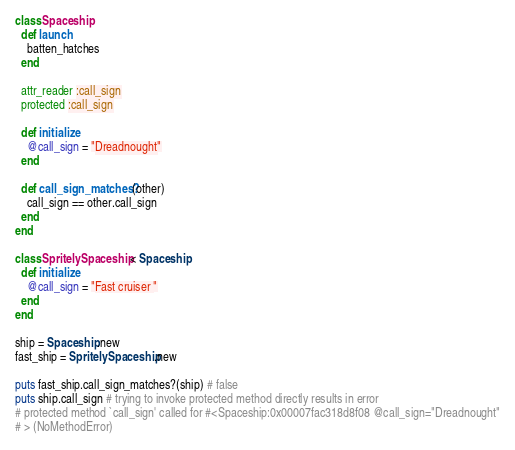<code> <loc_0><loc_0><loc_500><loc_500><_Ruby_>class Spaceship
  def launch
    batten_hatches
  end

  attr_reader :call_sign
  protected :call_sign

  def initialize
    @call_sign = "Dreadnought"
  end

  def call_sign_matches?(other)
    call_sign == other.call_sign
  end
end

class SpritelySpaceship < Spaceship
  def initialize
    @call_sign = "Fast cruiser "
  end
end

ship = Spaceship.new
fast_ship = SpritelySpaceship.new

puts fast_ship.call_sign_matches?(ship) # false
puts ship.call_sign # trying to invoke protected method directly results in error
# protected method `call_sign' called for #<Spaceship:0x00007fac318d8f08 @call_sign="Dreadnought"
# > (NoMethodError)</code> 